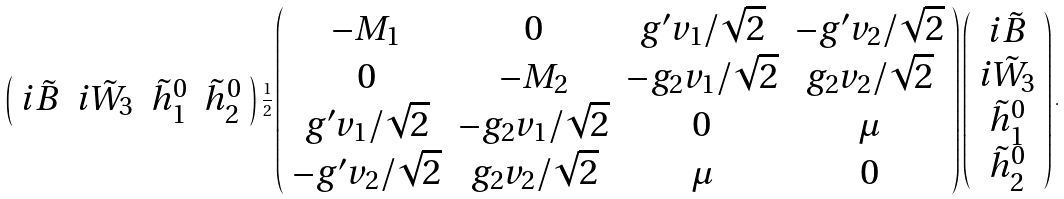<formula> <loc_0><loc_0><loc_500><loc_500>\left ( \begin{array} { c c c c } i \tilde { B } & i \tilde { W } _ { 3 } & \tilde { h } _ { 1 } ^ { 0 } & \tilde { h } _ { 2 } ^ { 0 } \end{array} \right ) \frac { 1 } { 2 } \left ( \begin{array} { c c c c } - M _ { 1 } & 0 & g ^ { \prime } v _ { 1 } / \sqrt { 2 } & - g ^ { \prime } v _ { 2 } / \sqrt { 2 } \\ 0 & - M _ { 2 } & - g _ { 2 } v _ { 1 } / \sqrt { 2 } & g _ { 2 } v _ { 2 } / \sqrt { 2 } \\ g ^ { \prime } v _ { 1 } / \sqrt { 2 } & - g _ { 2 } v _ { 1 } / \sqrt { 2 } & 0 & \mu \\ - g ^ { \prime } v _ { 2 } / \sqrt { 2 } & g _ { 2 } v _ { 2 } / \sqrt { 2 } & \mu & 0 \end{array} \right ) \left ( \begin{array} { c } i \tilde { B } \\ i \tilde { W } _ { 3 } \\ \tilde { h } _ { 1 } ^ { 0 } \\ \tilde { h } _ { 2 } ^ { 0 } \end{array} \right ) .</formula> 